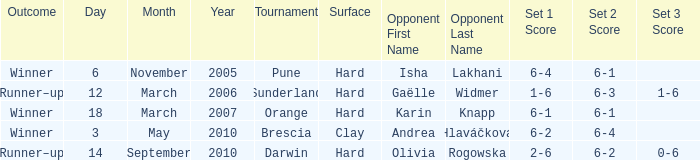When was the tournament at Orange? 18 March 2007. 